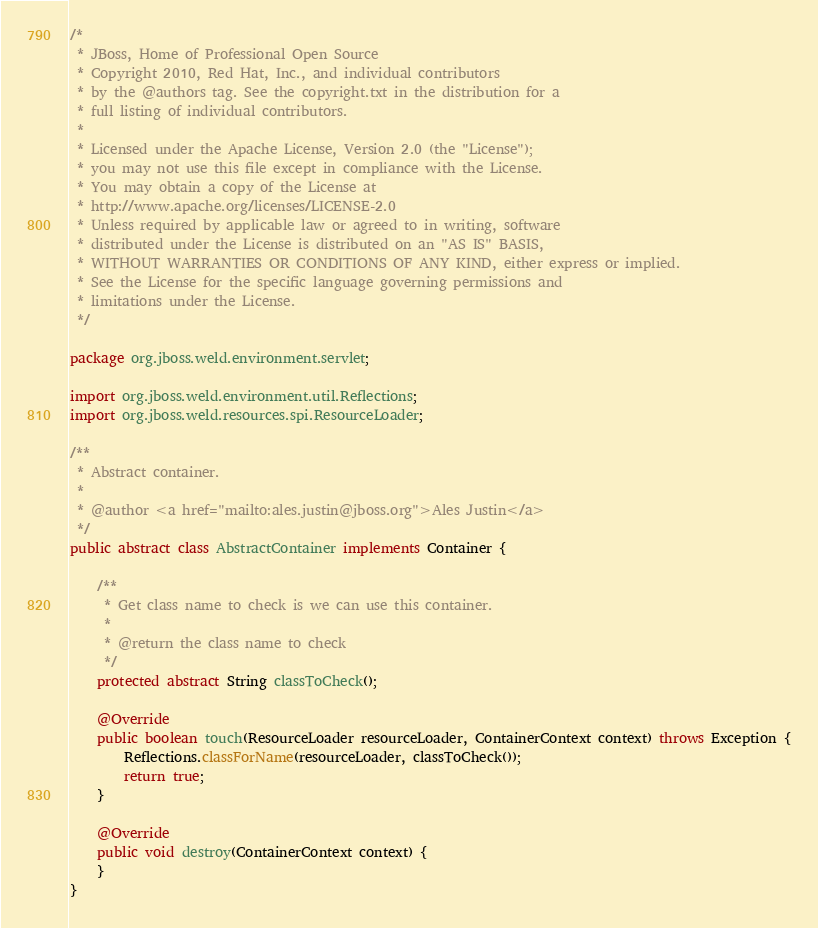Convert code to text. <code><loc_0><loc_0><loc_500><loc_500><_Java_>/*
 * JBoss, Home of Professional Open Source
 * Copyright 2010, Red Hat, Inc., and individual contributors
 * by the @authors tag. See the copyright.txt in the distribution for a
 * full listing of individual contributors.
 *
 * Licensed under the Apache License, Version 2.0 (the "License");
 * you may not use this file except in compliance with the License.
 * You may obtain a copy of the License at
 * http://www.apache.org/licenses/LICENSE-2.0
 * Unless required by applicable law or agreed to in writing, software
 * distributed under the License is distributed on an "AS IS" BASIS,
 * WITHOUT WARRANTIES OR CONDITIONS OF ANY KIND, either express or implied.
 * See the License for the specific language governing permissions and
 * limitations under the License.
 */

package org.jboss.weld.environment.servlet;

import org.jboss.weld.environment.util.Reflections;
import org.jboss.weld.resources.spi.ResourceLoader;

/**
 * Abstract container.
 *
 * @author <a href="mailto:ales.justin@jboss.org">Ales Justin</a>
 */
public abstract class AbstractContainer implements Container {

    /**
     * Get class name to check is we can use this container.
     *
     * @return the class name to check
     */
    protected abstract String classToCheck();

    @Override
    public boolean touch(ResourceLoader resourceLoader, ContainerContext context) throws Exception {
        Reflections.classForName(resourceLoader, classToCheck());
        return true;
    }

    @Override
    public void destroy(ContainerContext context) {
    }
}
</code> 